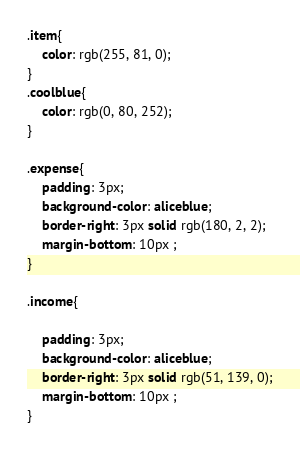Convert code to text. <code><loc_0><loc_0><loc_500><loc_500><_CSS_>.item{
    color: rgb(255, 81, 0);
}
.coolblue{
    color: rgb(0, 80, 252);
}

.expense{
    padding: 3px;
    background-color: aliceblue;
    border-right: 3px solid rgb(180, 2, 2);
    margin-bottom: 10px ;
}

.income{
    
    padding: 3px;
    background-color: aliceblue;
    border-right: 3px solid rgb(51, 139, 0);
    margin-bottom: 10px ;
}</code> 